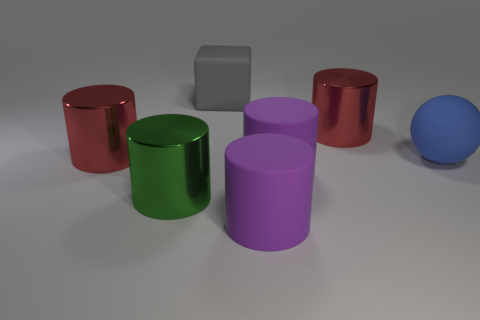There is a big cylinder that is both on the right side of the big green thing and behind the large matte ball; what is its material?
Your answer should be very brief. Metal. What shape is the big thing that is in front of the big shiny thing in front of the large blue sphere?
Keep it short and to the point. Cylinder. Does the block have the same color as the rubber sphere?
Your answer should be very brief. No. How many cyan objects are small metal things or shiny things?
Your answer should be compact. 0. Are there any purple things to the left of the gray thing?
Give a very brief answer. No. How big is the green metallic thing?
Offer a terse response. Large. There is a big shiny thing in front of the blue ball; how many blue matte objects are to the left of it?
Your response must be concise. 0. Does the big red cylinder that is on the left side of the rubber cube have the same material as the red cylinder that is right of the large gray matte block?
Make the answer very short. Yes. How many other matte things have the same shape as the blue rubber object?
Provide a short and direct response. 0. What number of large metal cylinders have the same color as the matte block?
Keep it short and to the point. 0. 